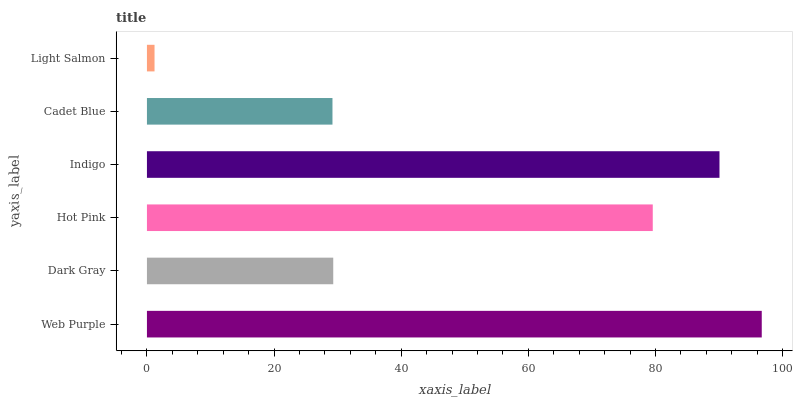Is Light Salmon the minimum?
Answer yes or no. Yes. Is Web Purple the maximum?
Answer yes or no. Yes. Is Dark Gray the minimum?
Answer yes or no. No. Is Dark Gray the maximum?
Answer yes or no. No. Is Web Purple greater than Dark Gray?
Answer yes or no. Yes. Is Dark Gray less than Web Purple?
Answer yes or no. Yes. Is Dark Gray greater than Web Purple?
Answer yes or no. No. Is Web Purple less than Dark Gray?
Answer yes or no. No. Is Hot Pink the high median?
Answer yes or no. Yes. Is Dark Gray the low median?
Answer yes or no. Yes. Is Cadet Blue the high median?
Answer yes or no. No. Is Hot Pink the low median?
Answer yes or no. No. 